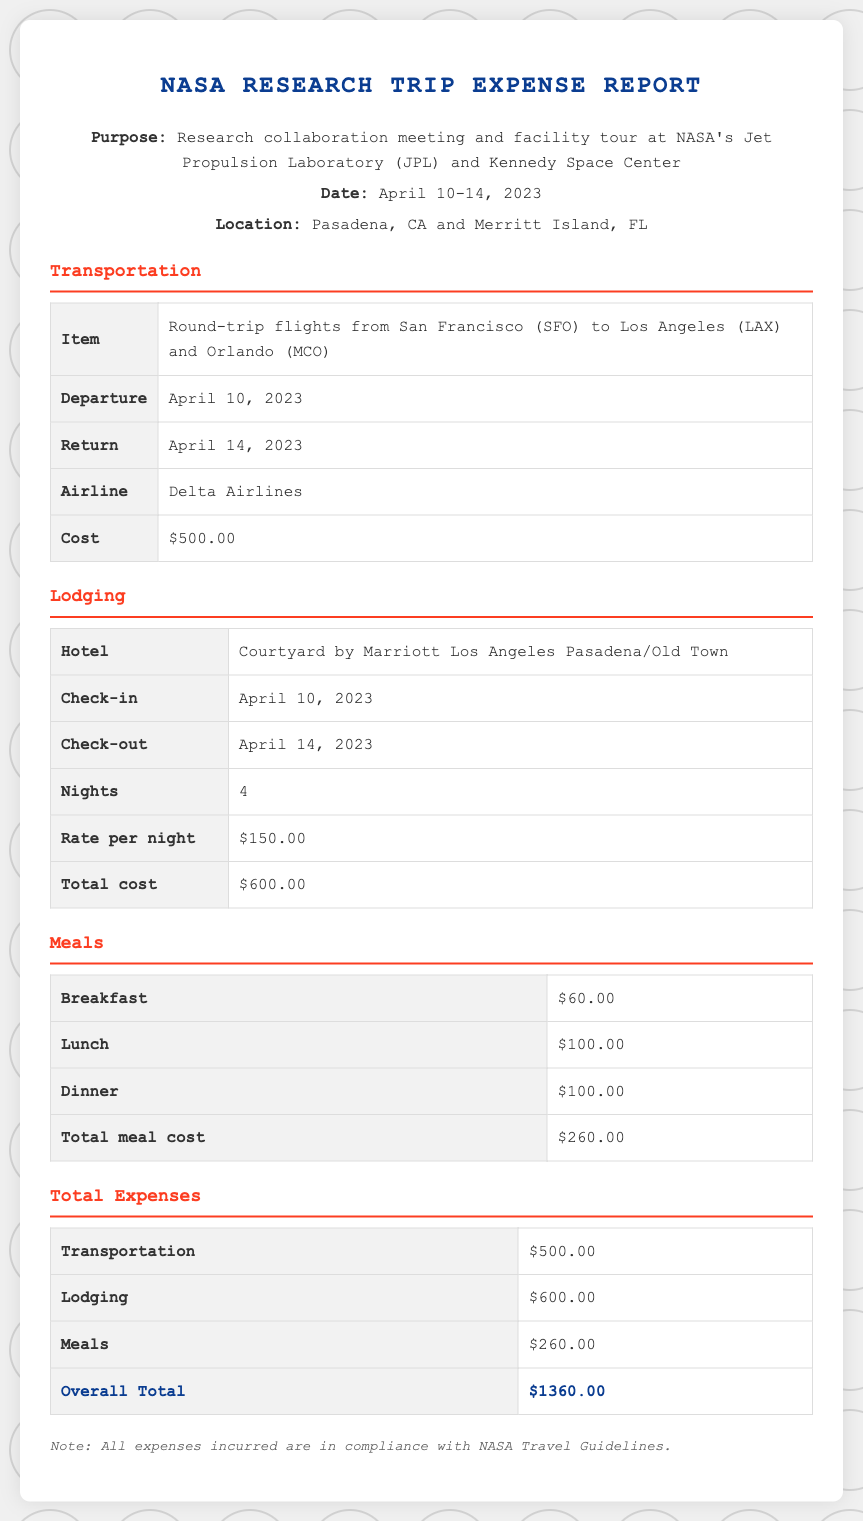What was the purpose of the trip? The purpose of the trip is stated in the document as a research collaboration meeting and facility tour at NASA's Jet Propulsion Laboratory (JPL) and Kennedy Space Center.
Answer: Research collaboration meeting and facility tour What are the check-in and check-out dates for lodging? The check-in date is April 10, 2023, and the check-out date is April 14, 2023.
Answer: April 10, 2023 and April 14, 2023 How many nights did the lodging last? The document specifies that the lodging lasted for 4 nights during the trip.
Answer: 4 What is the total cost for meals? The total meal cost is specified clearly in the document at $260.00.
Answer: $260.00 What is the overall total of all expenses? The overall total of all expenses is calculated in the document as $1360.00.
Answer: $1360.00 Which hotel was used for lodging? The hotel used for lodging is identified as Courtyard by Marriott Los Angeles Pasadena/Old Town.
Answer: Courtyard by Marriott Los Angeles Pasadena/Old Town What airline was used for transportation? The document states that Delta Airlines was the airline used for the round-trip flights.
Answer: Delta Airlines How much was spent on transportation? The document indicates that the total transportation cost was $500.00.
Answer: $500.00 